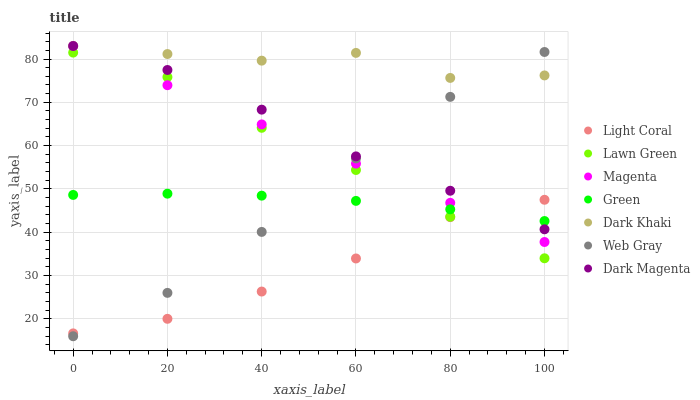Does Light Coral have the minimum area under the curve?
Answer yes or no. Yes. Does Dark Khaki have the maximum area under the curve?
Answer yes or no. Yes. Does Web Gray have the minimum area under the curve?
Answer yes or no. No. Does Web Gray have the maximum area under the curve?
Answer yes or no. No. Is Magenta the smoothest?
Answer yes or no. Yes. Is Dark Khaki the roughest?
Answer yes or no. Yes. Is Web Gray the smoothest?
Answer yes or no. No. Is Web Gray the roughest?
Answer yes or no. No. Does Web Gray have the lowest value?
Answer yes or no. Yes. Does Dark Magenta have the lowest value?
Answer yes or no. No. Does Magenta have the highest value?
Answer yes or no. Yes. Does Web Gray have the highest value?
Answer yes or no. No. Is Light Coral less than Dark Khaki?
Answer yes or no. Yes. Is Dark Khaki greater than Light Coral?
Answer yes or no. Yes. Does Dark Khaki intersect Dark Magenta?
Answer yes or no. Yes. Is Dark Khaki less than Dark Magenta?
Answer yes or no. No. Is Dark Khaki greater than Dark Magenta?
Answer yes or no. No. Does Light Coral intersect Dark Khaki?
Answer yes or no. No. 